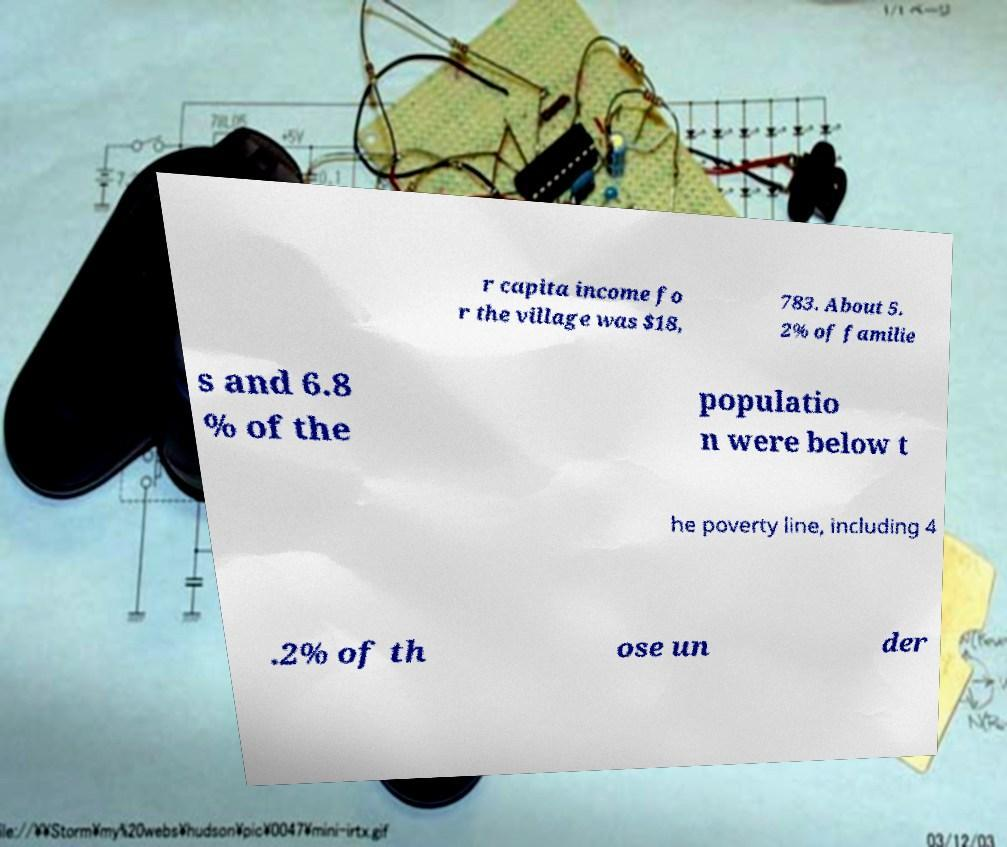For documentation purposes, I need the text within this image transcribed. Could you provide that? r capita income fo r the village was $18, 783. About 5. 2% of familie s and 6.8 % of the populatio n were below t he poverty line, including 4 .2% of th ose un der 